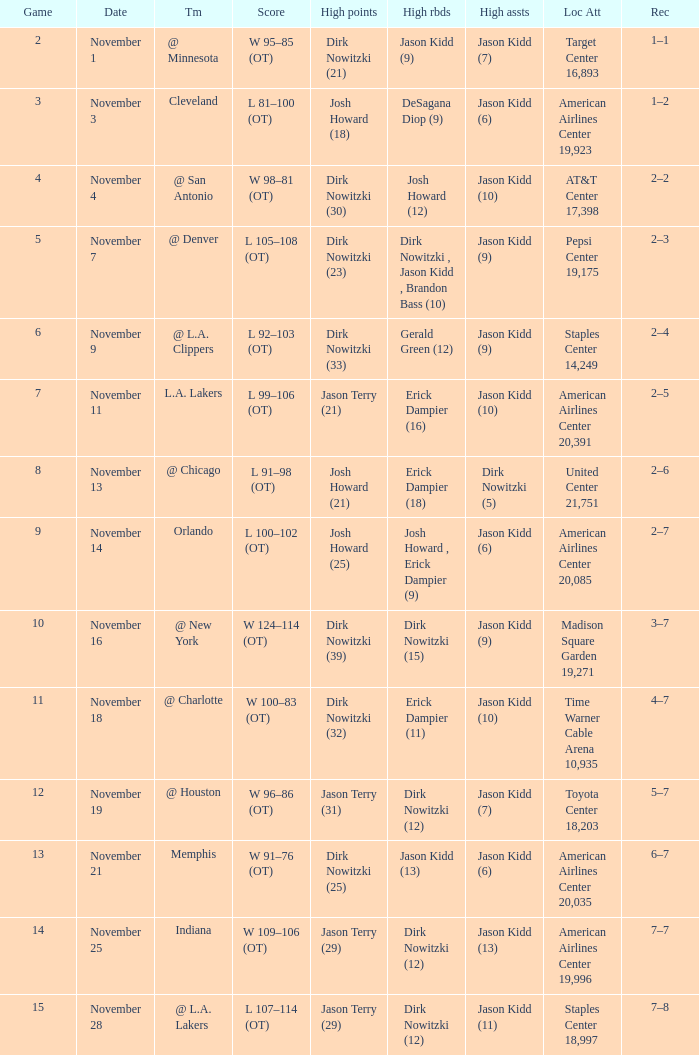What was the record on November 1? 1–1. 